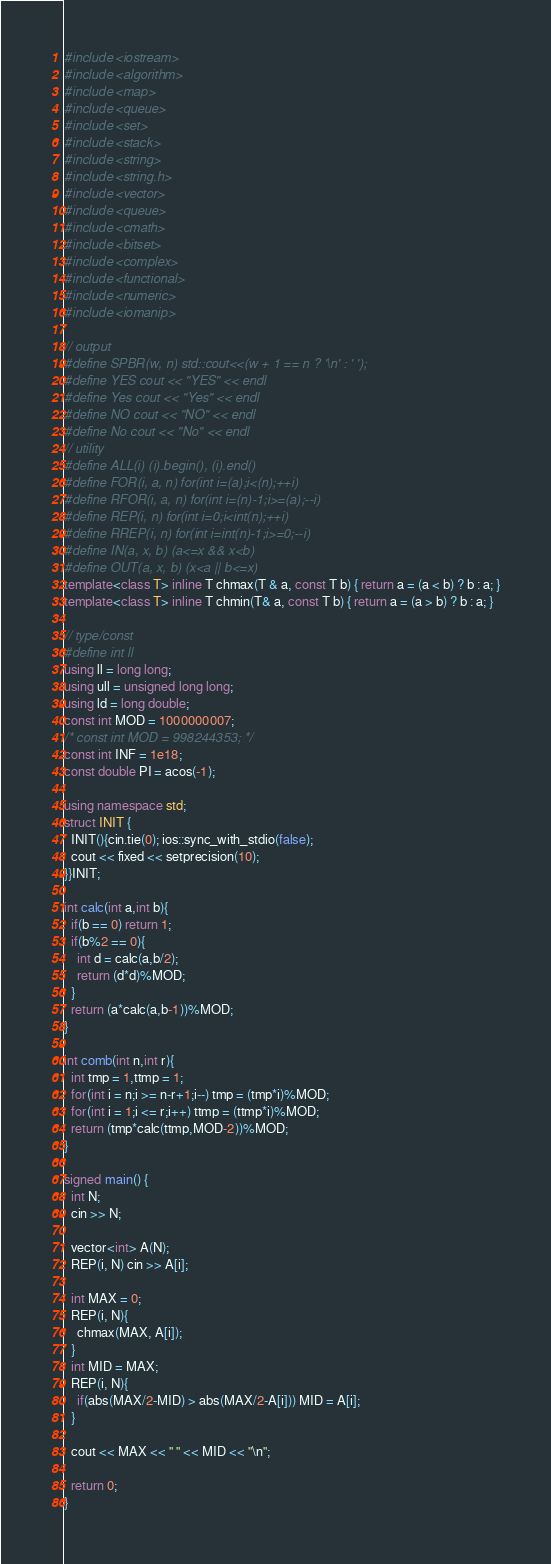Convert code to text. <code><loc_0><loc_0><loc_500><loc_500><_C++_>#include <iostream>
#include <algorithm>
#include <map>
#include <queue>
#include <set>
#include <stack>
#include <string>
#include <string.h>
#include <vector>
#include <queue>
#include <cmath>
#include <bitset>
#include <complex>
#include <functional>
#include <numeric>
#include <iomanip>

// output
#define SPBR(w, n) std::cout<<(w + 1 == n ? '\n' : ' ');
#define YES cout << "YES" << endl
#define Yes cout << "Yes" << endl
#define NO cout << "NO" << endl
#define No cout << "No" << endl
// utility
#define ALL(i) (i).begin(), (i).end()
#define FOR(i, a, n) for(int i=(a);i<(n);++i)
#define RFOR(i, a, n) for(int i=(n)-1;i>=(a);--i)
#define REP(i, n) for(int i=0;i<int(n);++i)
#define RREP(i, n) for(int i=int(n)-1;i>=0;--i)
#define IN(a, x, b) (a<=x && x<b)
#define OUT(a, x, b) (x<a || b<=x)
template<class T> inline T chmax(T & a, const T b) { return a = (a < b) ? b : a; }
template<class T> inline T chmin(T& a, const T b) { return a = (a > b) ? b : a; }

// type/const
#define int ll
using ll = long long;
using ull = unsigned long long;
using ld = long double;
const int MOD = 1000000007;
/* const int MOD = 998244353; */
const int INF = 1e18;
const double PI = acos(-1);

using namespace std;
struct INIT { 
  INIT(){cin.tie(0); ios::sync_with_stdio(false);
  cout << fixed << setprecision(10);
}}INIT;

int calc(int a,int b){
  if(b == 0) return 1;
  if(b%2 == 0){
    int d = calc(a,b/2);
    return (d*d)%MOD;
  }
  return (a*calc(a,b-1))%MOD;
}

int comb(int n,int r){
  int tmp = 1,ttmp = 1;
  for(int i = n;i >= n-r+1;i--) tmp = (tmp*i)%MOD;
  for(int i = 1;i <= r;i++) ttmp = (ttmp*i)%MOD;
  return (tmp*calc(ttmp,MOD-2))%MOD;
}

signed main() {
  int N; 
  cin >> N;

  vector<int> A(N);
  REP(i, N) cin >> A[i];

  int MAX = 0;
  REP(i, N){
    chmax(MAX, A[i]);
  }
  int MID = MAX;
  REP(i, N){
    if(abs(MAX/2-MID) > abs(MAX/2-A[i])) MID = A[i];
  }

  cout << MAX << " " << MID << "\n";

  return 0;
}</code> 